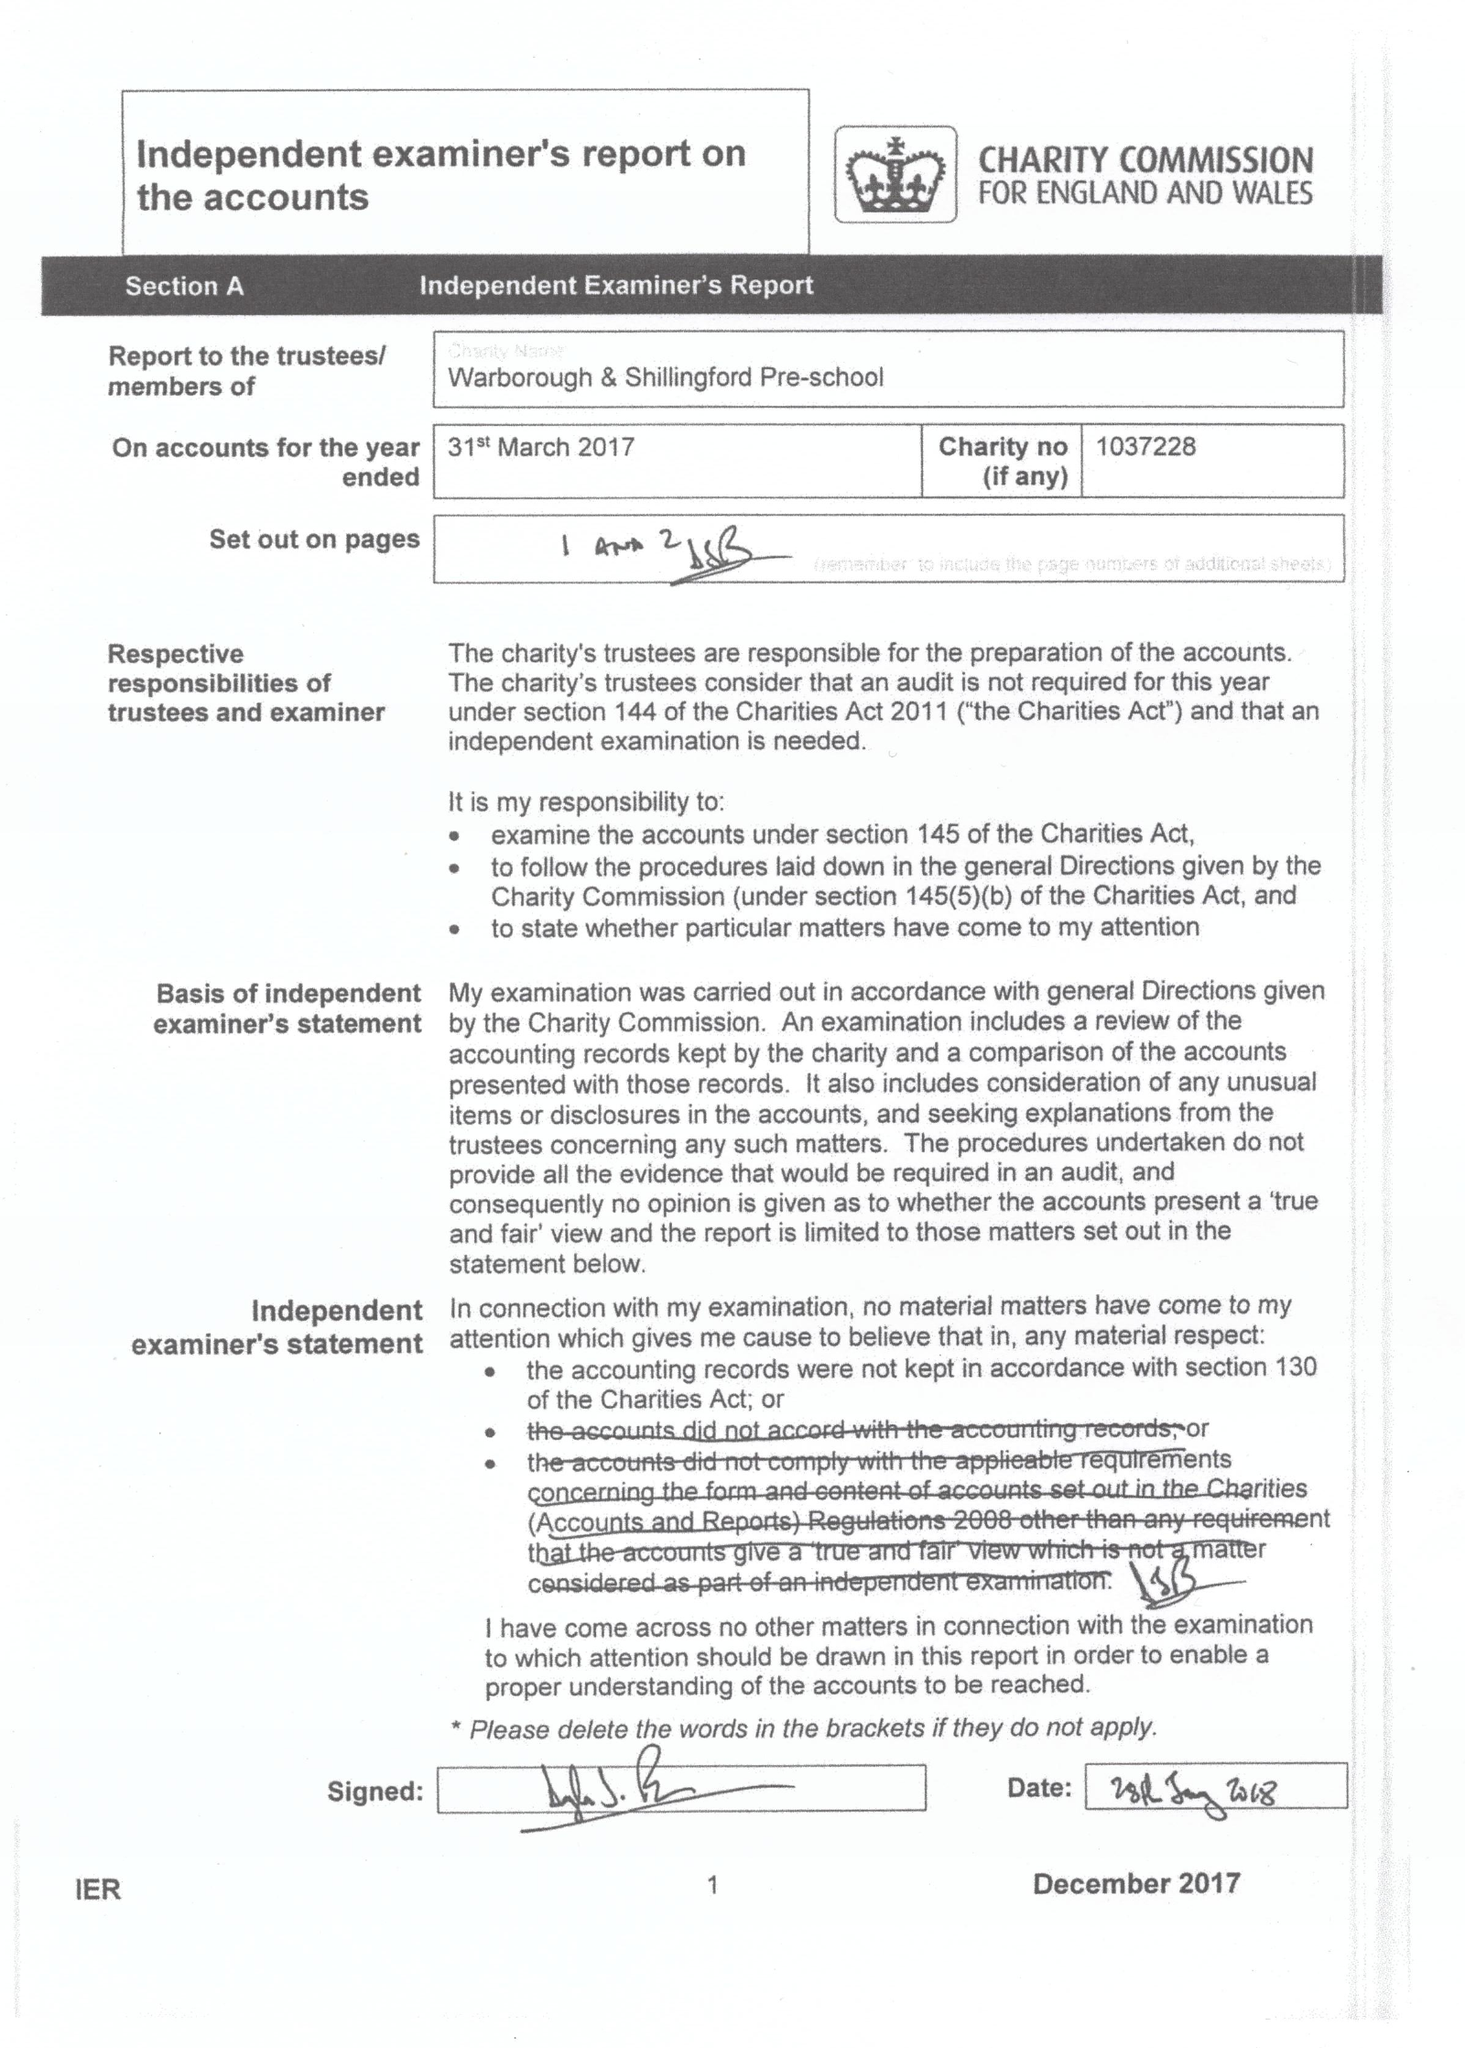What is the value for the address__postcode?
Answer the question using a single word or phrase. OX10 7DX 